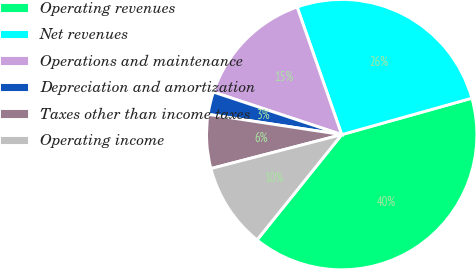Convert chart to OTSL. <chart><loc_0><loc_0><loc_500><loc_500><pie_chart><fcel>Operating revenues<fcel>Net revenues<fcel>Operations and maintenance<fcel>Depreciation and amortization<fcel>Taxes other than income taxes<fcel>Operating income<nl><fcel>40.12%<fcel>26.01%<fcel>14.55%<fcel>2.7%<fcel>6.44%<fcel>10.18%<nl></chart> 